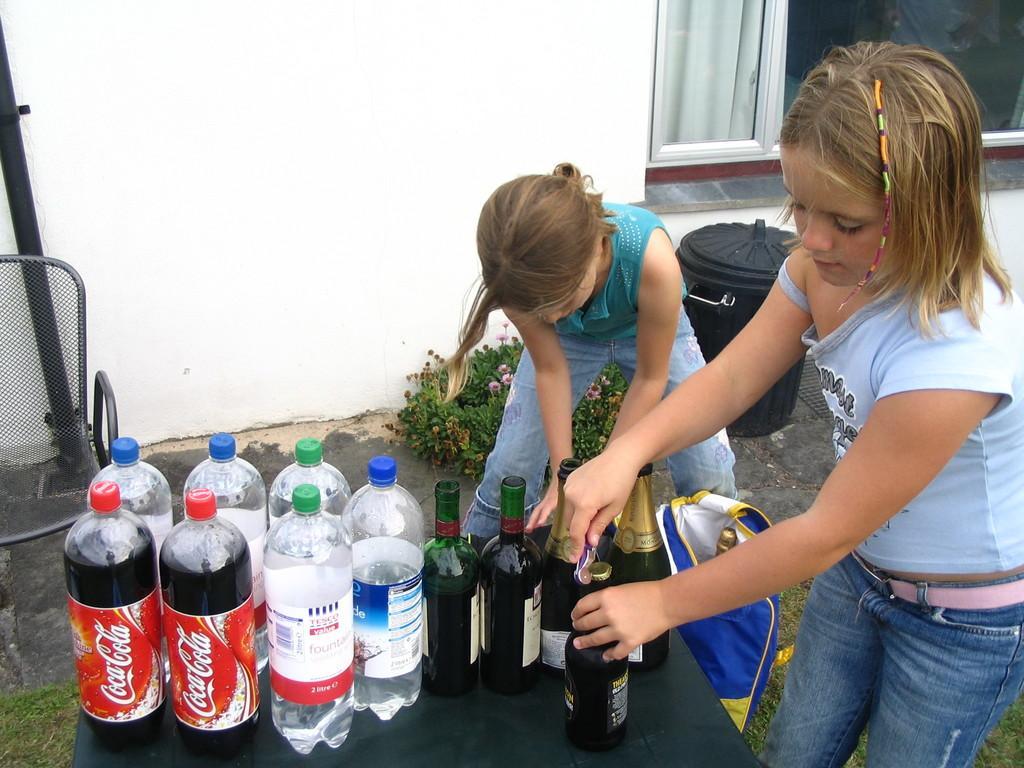Could you give a brief overview of what you see in this image? In this see image I can see two girls are standing. Here I can see number of bottles. In the background I can see a plant and a container. 